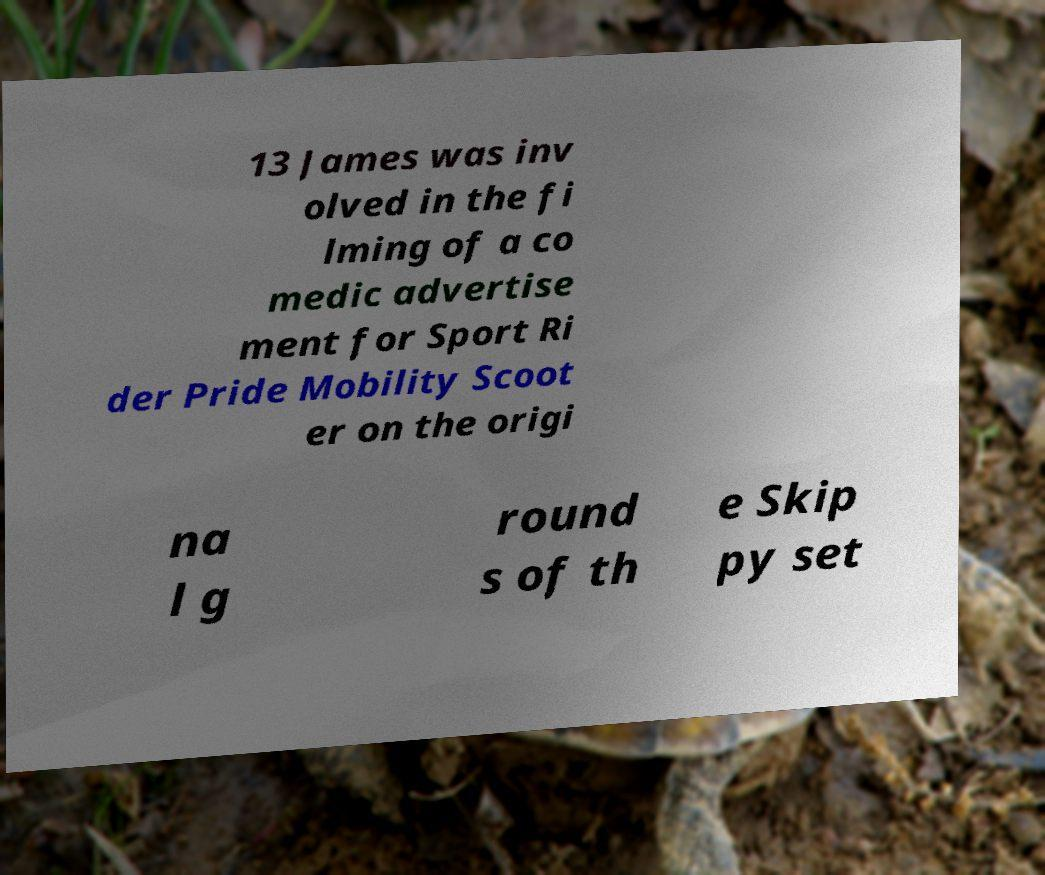What messages or text are displayed in this image? I need them in a readable, typed format. 13 James was inv olved in the fi lming of a co medic advertise ment for Sport Ri der Pride Mobility Scoot er on the origi na l g round s of th e Skip py set 